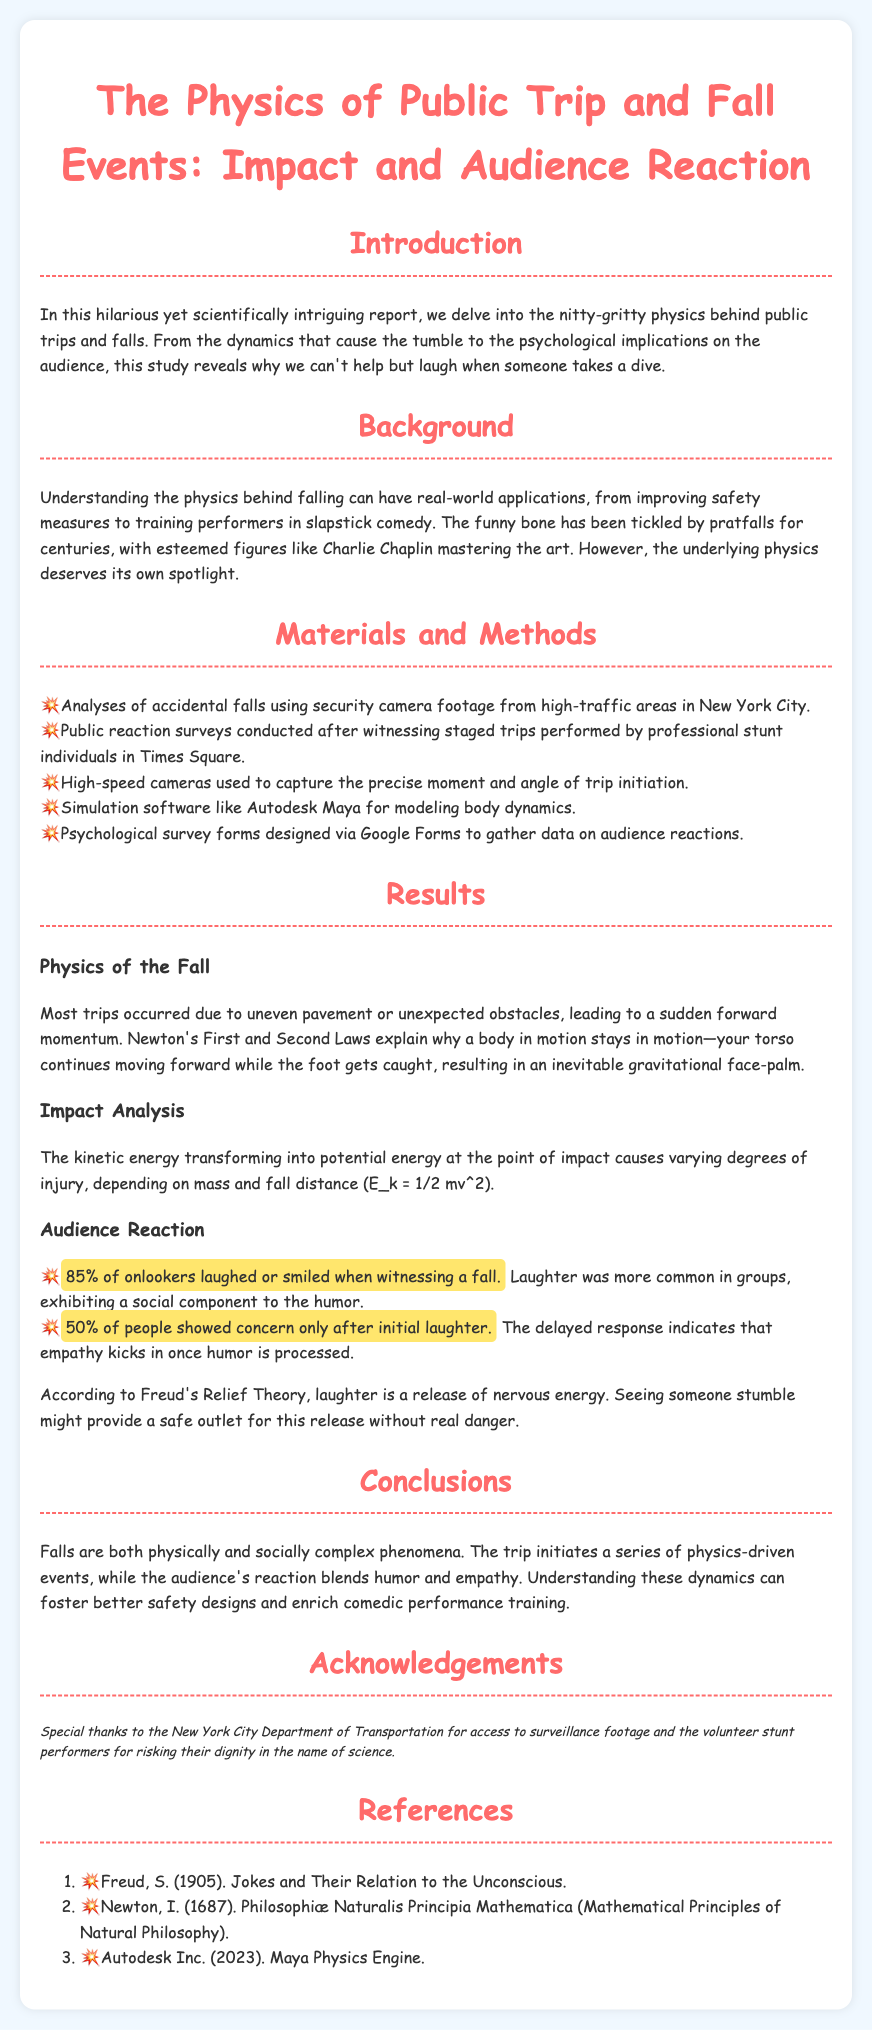What is the title of the report? The title is specified in the header of the document.
Answer: The Physics of Public Trip and Fall Events: Impact and Audience Reaction What percentage of onlookers laughed or smiled? This statistic is provided in the results section regarding audience reaction.
Answer: 85% What theory explains the humor in witnessing a fall? The document references a specific psychological theory related to humor.
Answer: Freud's Relief Theory What material was used to analyze accidental falls? The methods section describes the type of material utilized for analysis.
Answer: Security camera footage What was the main cause of most trips identified in the results? The report discusses causal factors related to falls in the results section.
Answer: Uneven pavement What year was "Philosophiæ Naturalis Principia Mathematica" published? The reference section provides the year of publication for this work.
Answer: 1687 What is the purpose of understanding the physics behind falling? The introduction emphasizes the motivation behind researching this topic.
Answer: Improving safety measures How many people showed concern only after initial laughter? The results section provides a specific percentage related to audience reactions.
Answer: 50% 